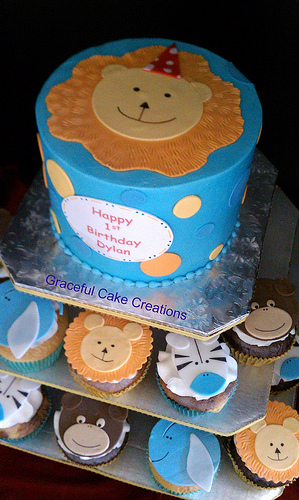<image>
Is the zebra on the elephant? No. The zebra is not positioned on the elephant. They may be near each other, but the zebra is not supported by or resting on top of the elephant. 